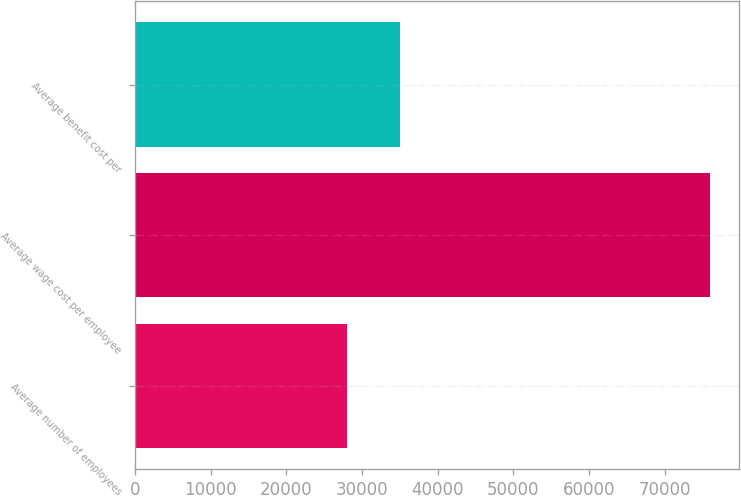<chart> <loc_0><loc_0><loc_500><loc_500><bar_chart><fcel>Average number of employees<fcel>Average wage cost per employee<fcel>Average benefit cost per<nl><fcel>28044<fcel>76000<fcel>35000<nl></chart> 